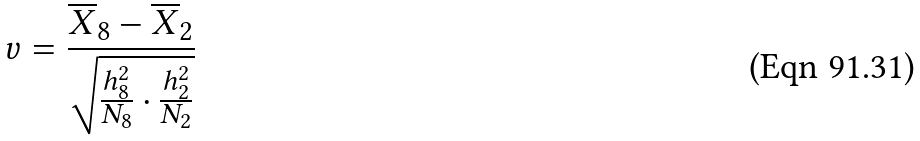Convert formula to latex. <formula><loc_0><loc_0><loc_500><loc_500>v = \frac { \overline { X } _ { 8 } - \overline { X } _ { 2 } } { \sqrt { \frac { h _ { 8 } ^ { 2 } } { N _ { 8 } } \cdot \frac { h _ { 2 } ^ { 2 } } { N _ { 2 } } } }</formula> 